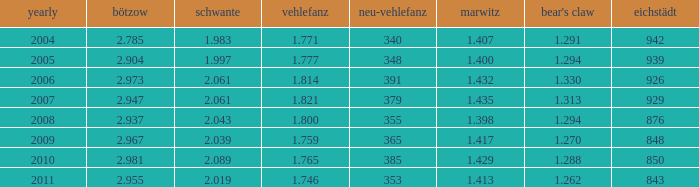What year has a Schwante smaller than 2.043, an Eichstädt smaller than 848, and a Bärenklau smaller than 1.262? 0.0. 